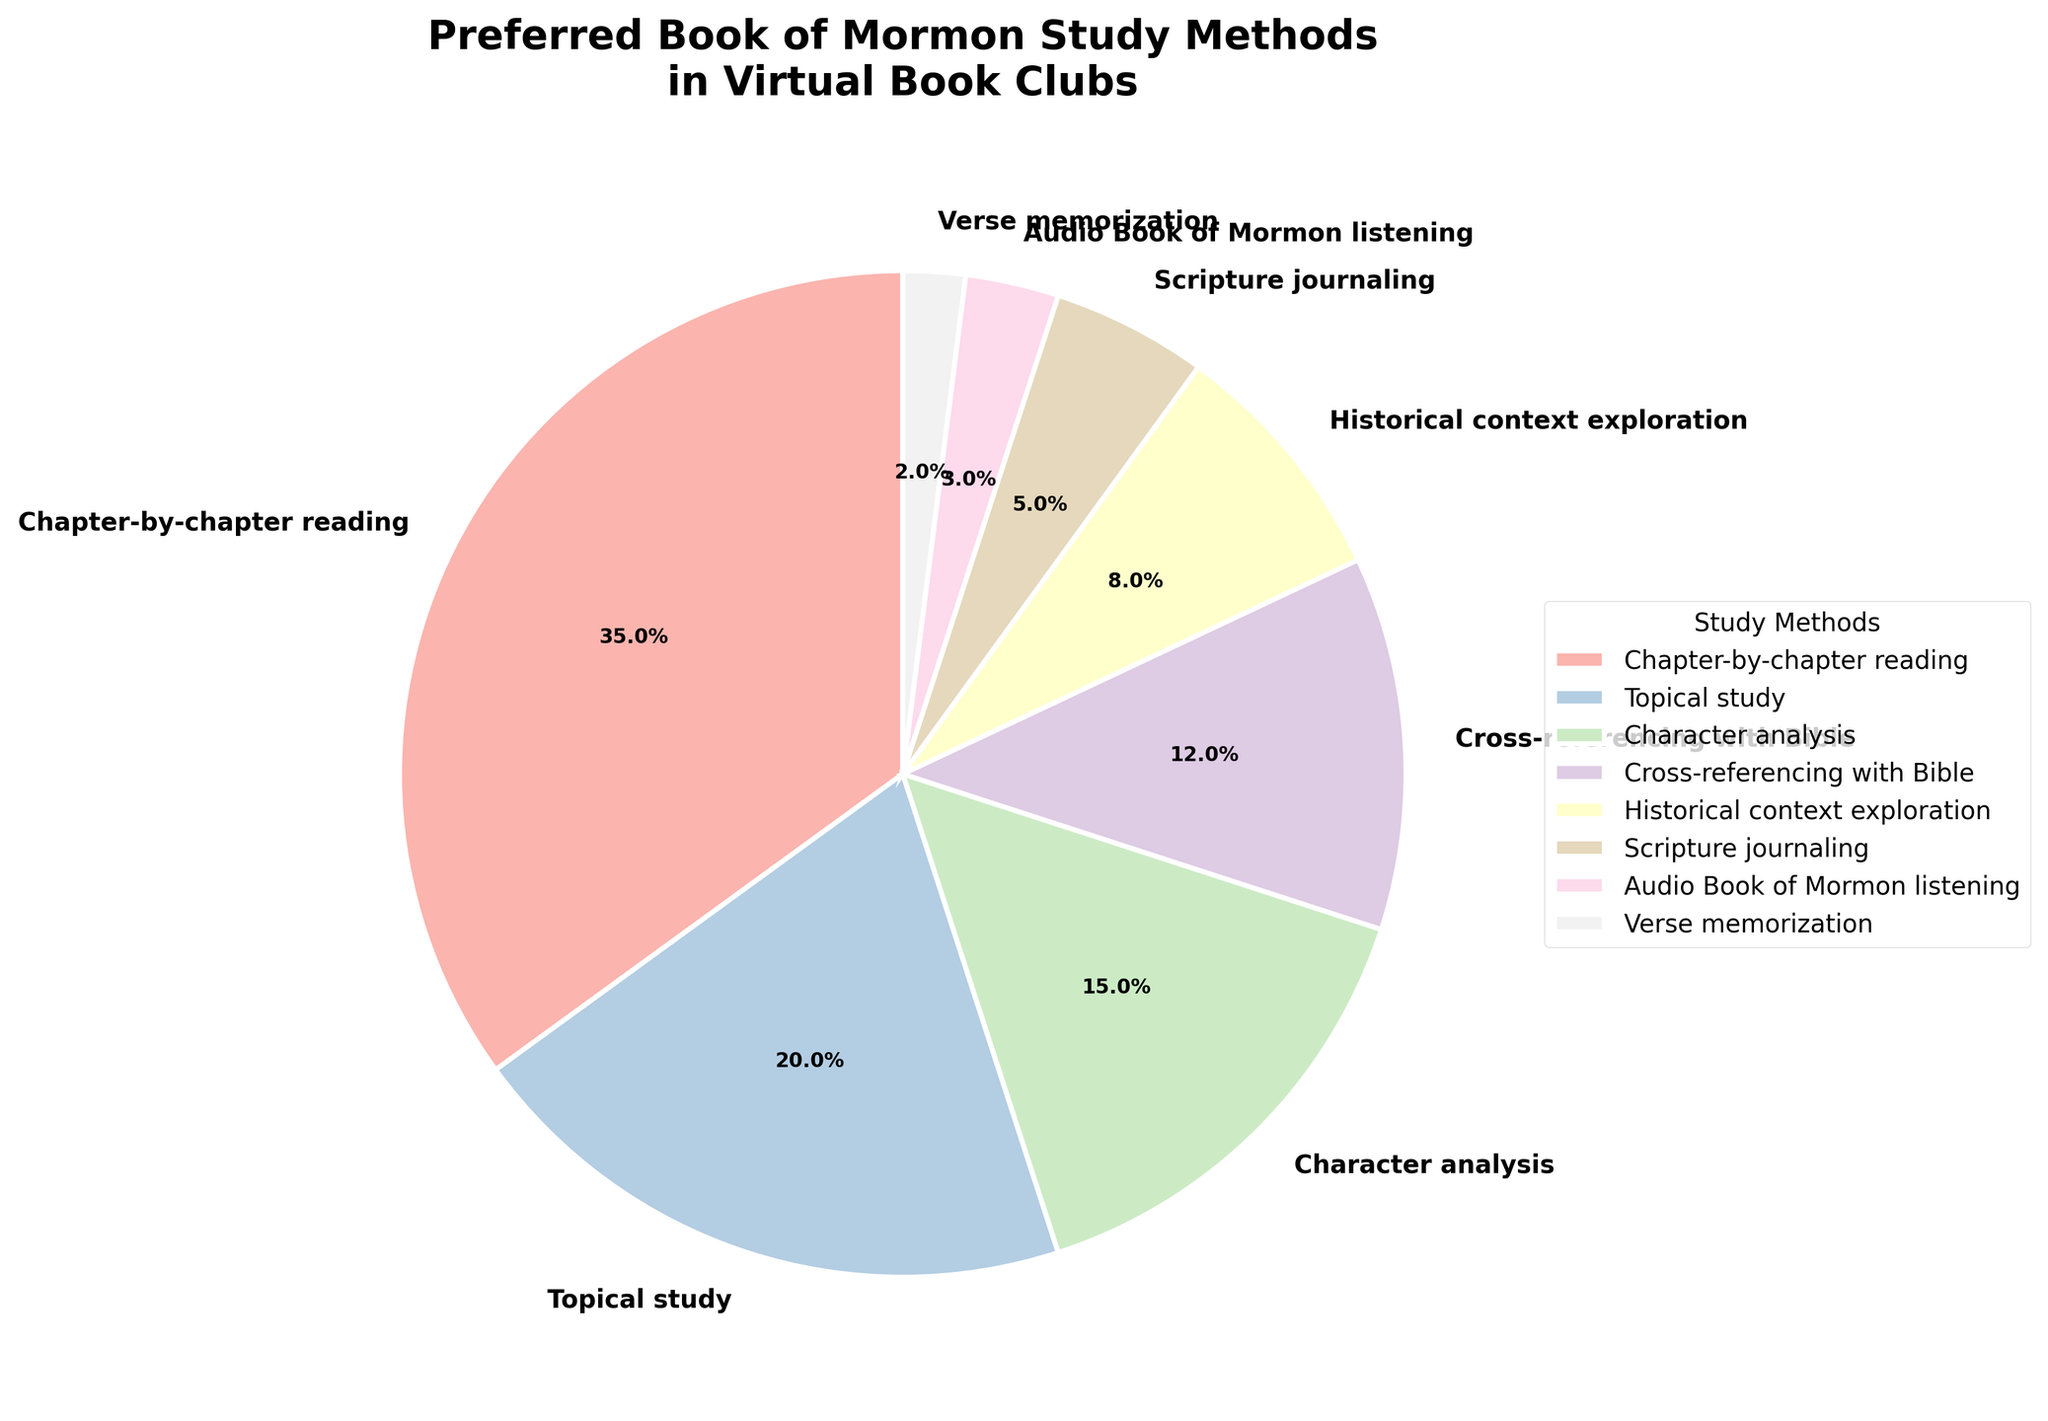Which study method is the most preferred among virtual book club members? The largest slice of the pie chart represents the most preferred study method. The slice labeled "Chapter-by-chapter reading" is the largest, occupying 35% of the pie.
Answer: Chapter-by-chapter reading How much more popular is chapter-by-chapter reading compared to topical study? Chapter-by-chapter reading is 35% and topical study is 20%. The additional preference for chapter-by-chapter reading is calculated by subtracting 20% from 35%, giving 15%.
Answer: 15% What is the combined percentage of people who prefer historical context exploration and scripture journaling? The pie chart shows historical context exploration at 8% and scripture journaling at 5%. Adding these two percentages gives a total of 13%.
Answer: 13% Which study method has the least preference among virtual book club members? The smallest slice of the pie chart represents the least preferred method. The slice labeled "Verse memorization" occupies 2%.
Answer: Verse memorization Is character analysis more popular than cross-referencing with the Bible? The pie chart shows that character analysis has a percentage of 15%, whereas cross-referencing with the Bible has 12%. Therefore, character analysis is indeed more popular.
Answer: Yes What percentage of participants prefer methods other than chapter-by-chapter reading? Chapter-by-chapter reading is preferred by 35%, so the percentage of participants preferring other methods is 100% - 35%, which equals 65%.
Answer: 65% How does the popularity of topical study compare to that of historical context exploration? Topical study is at 20% and historical context exploration is at 8% according to the pie chart. Since 20% is greater than 8%, topical study is more popular.
Answer: More popular What is the difference in preference between audio Book of Mormon listening and verse memorization? Audio Book of Mormon listening has a preference of 3%, while verse memorization has 2%. The difference is 3% - 2%, which is 1%.
Answer: 1% If we consider the three methods with the lowest percentages, what is their combined preference? The three methods with the lowest percentages are audio Book of Mormon listening (3%), verse memorization (2%), and scripture journaling (5%). Adding these gives 3% + 2% + 5% = 10%.
Answer: 10% Which method ranks third in terms of preference, and what is its percentage? According to the pie chart, the third-largest slice corresponds to character analysis, which occupies 15% of the pie.
Answer: Character analysis, 15% 